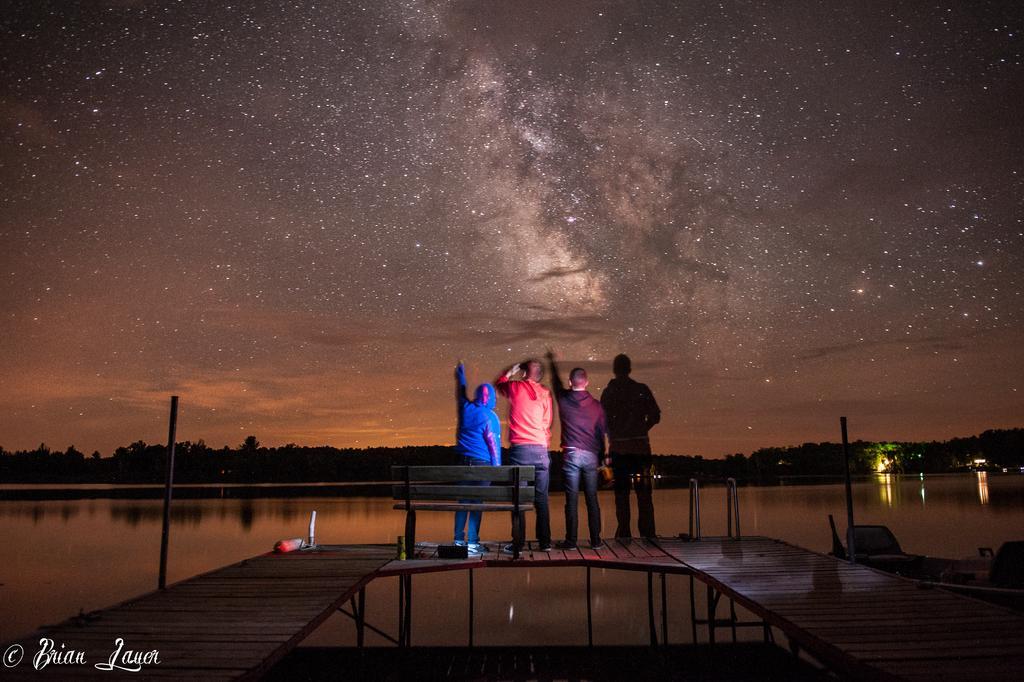Describe this image in one or two sentences. In this picture we can see four people standing on the bridge and in the background we can see water,trees,sky. 